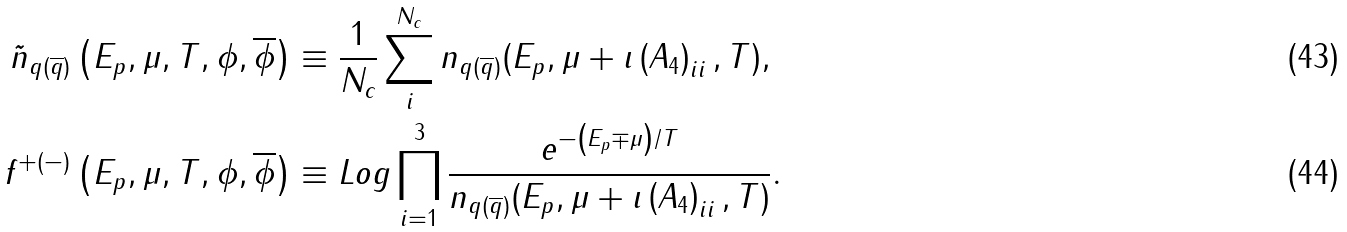Convert formula to latex. <formula><loc_0><loc_0><loc_500><loc_500>\tilde { n } _ { q ( \overline { q } ) } \left ( E _ { p } , \mu , T , \phi , \overline { \phi } \right ) & \equiv \frac { 1 } { N _ { c } } \sum _ { i } ^ { N _ { c } } n _ { q ( \overline { q } ) } ( E _ { p } , \mu + \imath \left ( A _ { 4 } \right ) _ { i i } , T ) , \\ f ^ { + ( - ) } \left ( E _ { p } , \mu , T , \phi , \overline { \phi } \right ) & \equiv L o g \prod ^ { 3 } _ { i = 1 } \frac { e ^ { - \left ( E _ { p } \mp \mu \right ) / T } } { n _ { q ( \overline { q } ) } ( E _ { p } , \mu + \imath \left ( A _ { 4 } \right ) _ { i i } , T ) } .</formula> 